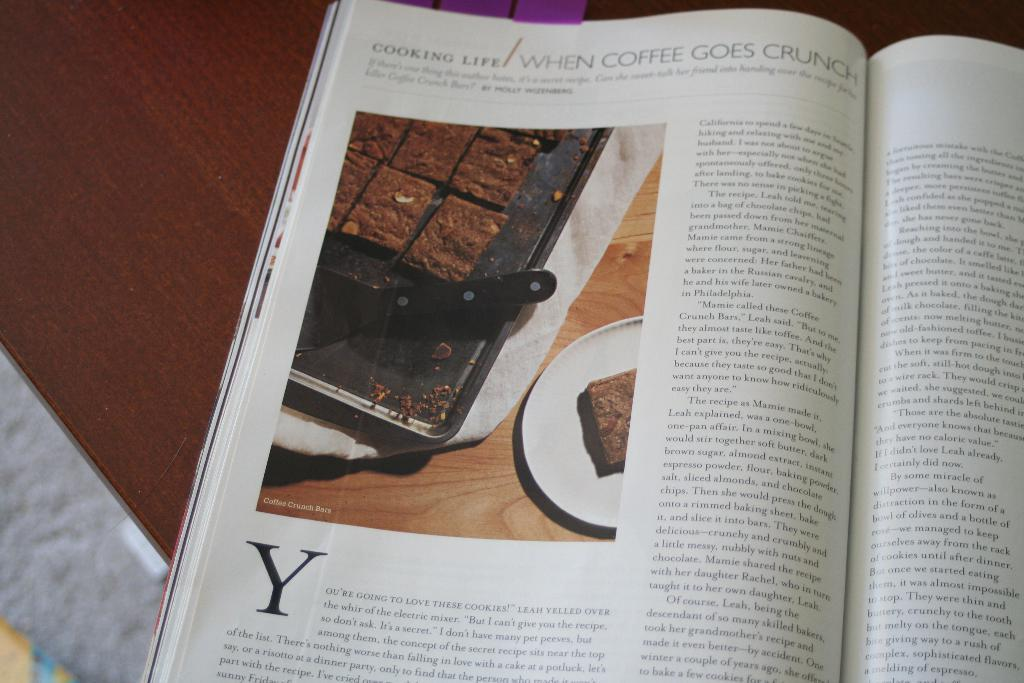<image>
Offer a succinct explanation of the picture presented. A magazine article on using coffee in baking recipes. 